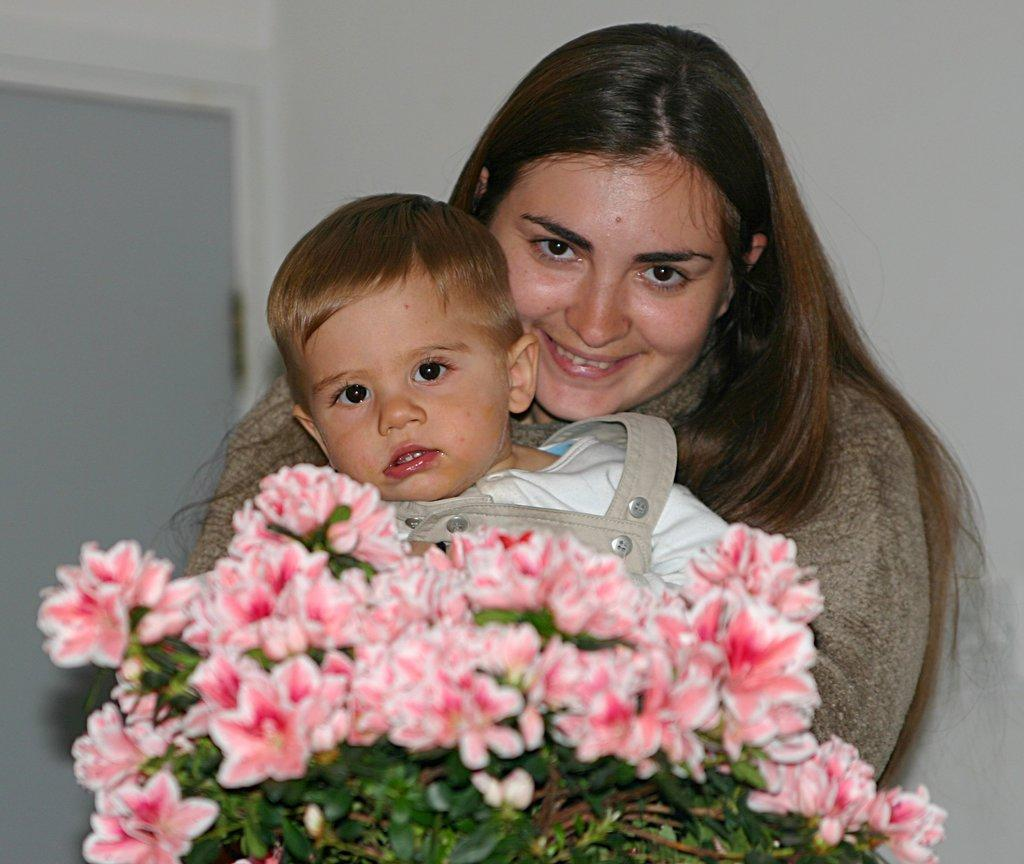Who is present in the image? There is a woman in the image. What is the woman doing in the image? The woman is holding a kid and smiling. What can be seen in the image besides the woman and the kid? There is a plant with flowers, a wall, and a door in the background of the image. How many snails can be seen crawling on the wall in the image? There are no snails visible in the image; only a woman, a kid, a plant with flowers, a wall, and a door are present. 